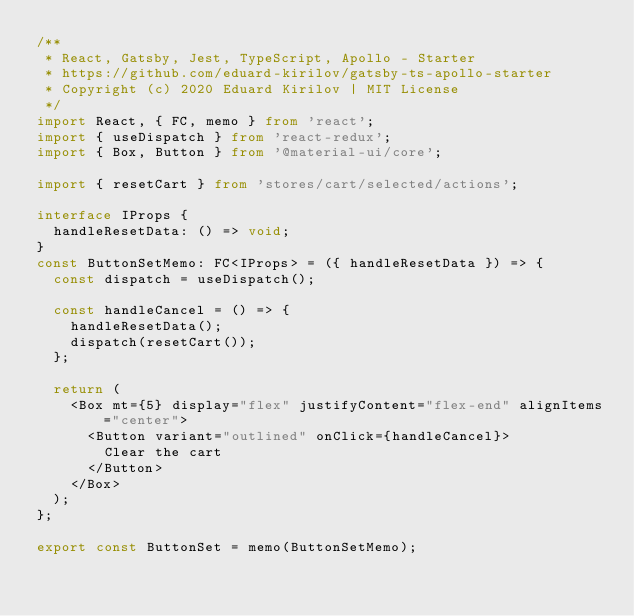Convert code to text. <code><loc_0><loc_0><loc_500><loc_500><_TypeScript_>/**
 * React, Gatsby, Jest, TypeScript, Apollo - Starter
 * https://github.com/eduard-kirilov/gatsby-ts-apollo-starter
 * Copyright (c) 2020 Eduard Kirilov | MIT License
 */
import React, { FC, memo } from 'react';
import { useDispatch } from 'react-redux';
import { Box, Button } from '@material-ui/core';

import { resetCart } from 'stores/cart/selected/actions';

interface IProps {
  handleResetData: () => void;
}
const ButtonSetMemo: FC<IProps> = ({ handleResetData }) => {
  const dispatch = useDispatch();

  const handleCancel = () => {
    handleResetData();
    dispatch(resetCart());
  };

  return (
    <Box mt={5} display="flex" justifyContent="flex-end" alignItems="center">
      <Button variant="outlined" onClick={handleCancel}>
        Clear the cart
      </Button>
    </Box>
  );
};

export const ButtonSet = memo(ButtonSetMemo);
</code> 